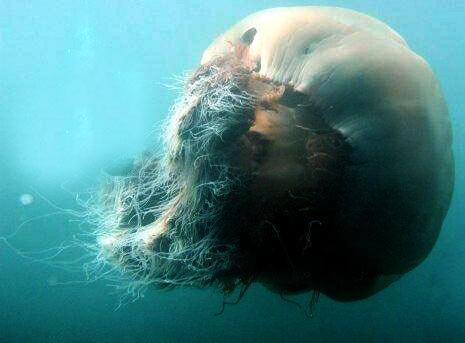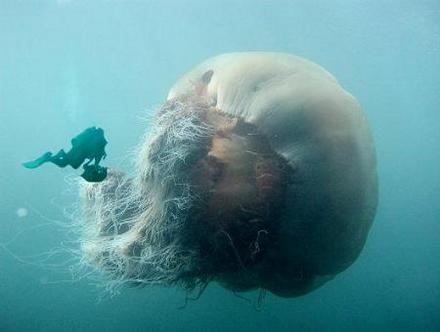The first image is the image on the left, the second image is the image on the right. Evaluate the accuracy of this statement regarding the images: "There is scuba diver in the image on the right.". Is it true? Answer yes or no. Yes. The first image is the image on the left, the second image is the image on the right. Evaluate the accuracy of this statement regarding the images: "Left image includes a diver wearing goggles.". Is it true? Answer yes or no. No. 